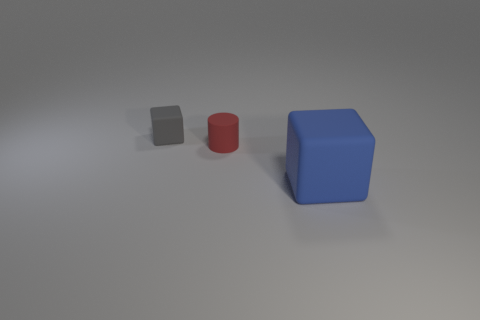Add 2 big yellow blocks. How many objects exist? 5 Subtract all cylinders. How many objects are left? 2 Subtract 0 blue spheres. How many objects are left? 3 Subtract all big blue blocks. Subtract all large gray matte balls. How many objects are left? 2 Add 3 red things. How many red things are left? 4 Add 1 tiny matte cylinders. How many tiny matte cylinders exist? 2 